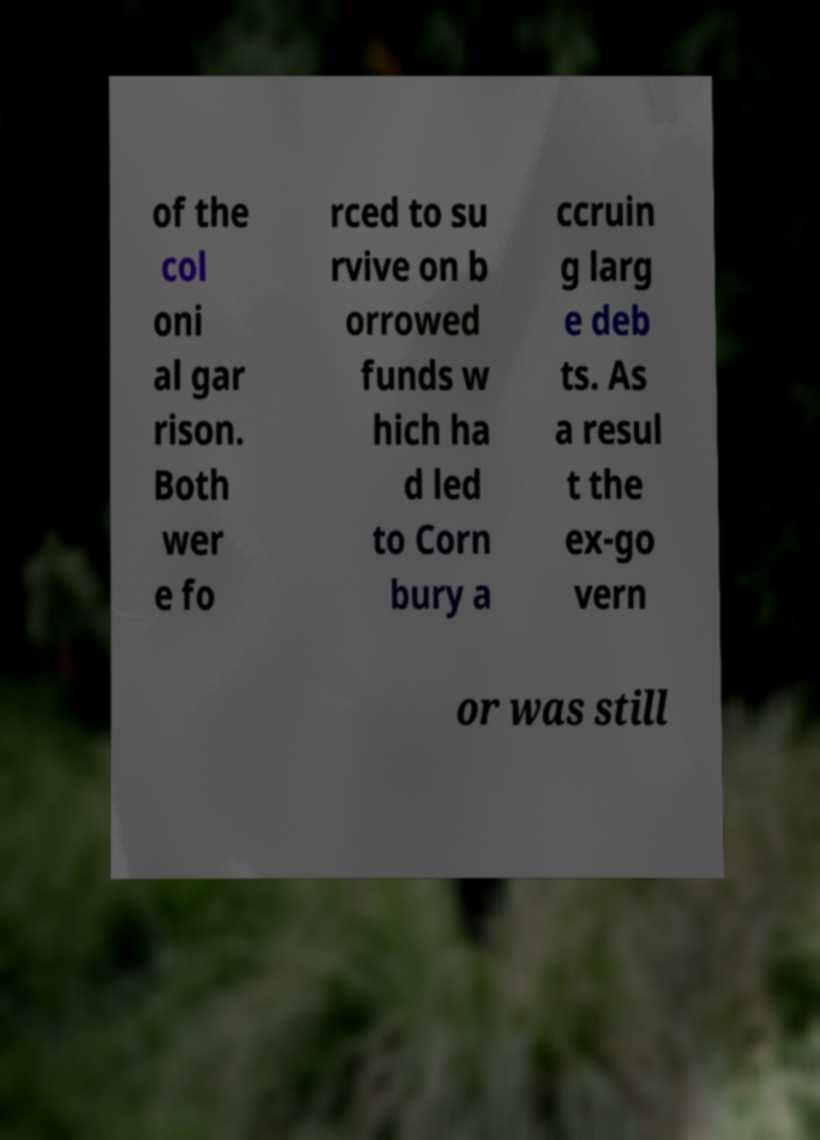There's text embedded in this image that I need extracted. Can you transcribe it verbatim? of the col oni al gar rison. Both wer e fo rced to su rvive on b orrowed funds w hich ha d led to Corn bury a ccruin g larg e deb ts. As a resul t the ex-go vern or was still 